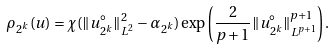<formula> <loc_0><loc_0><loc_500><loc_500>\rho _ { 2 ^ { k } } ( u ) = \chi ( \| u _ { 2 ^ { k } } ^ { \circ } \| _ { L ^ { 2 } } ^ { 2 } - \alpha _ { 2 ^ { k } } ) \exp \left ( \frac { 2 } { p + 1 } \| u _ { 2 ^ { k } } ^ { \circ } \| _ { L ^ { p + 1 } } ^ { p + 1 } \right ) .</formula> 